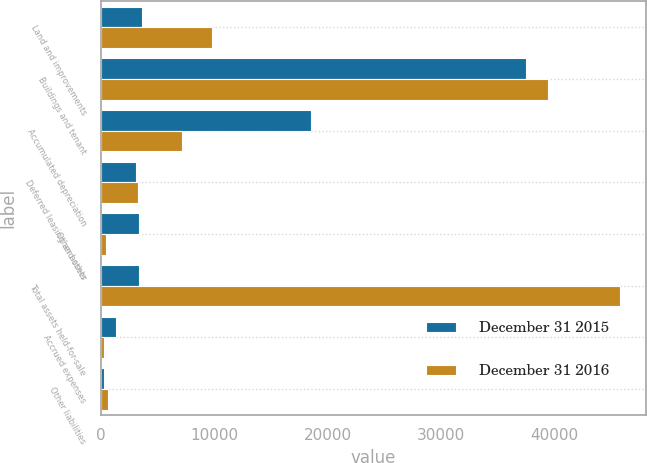<chart> <loc_0><loc_0><loc_500><loc_500><stacked_bar_chart><ecel><fcel>Land and improvements<fcel>Buildings and tenant<fcel>Accumulated depreciation<fcel>Deferred leasing and other<fcel>Other assets<fcel>Total assets held-for-sale<fcel>Accrued expenses<fcel>Other liabilities<nl><fcel>December 31 2015<fcel>3631<fcel>37495<fcel>18581<fcel>3091<fcel>3334<fcel>3334<fcel>1363<fcel>298<nl><fcel>December 31 2016<fcel>9797<fcel>39480<fcel>7183<fcel>3293<fcel>414<fcel>45801<fcel>322<fcel>650<nl></chart> 